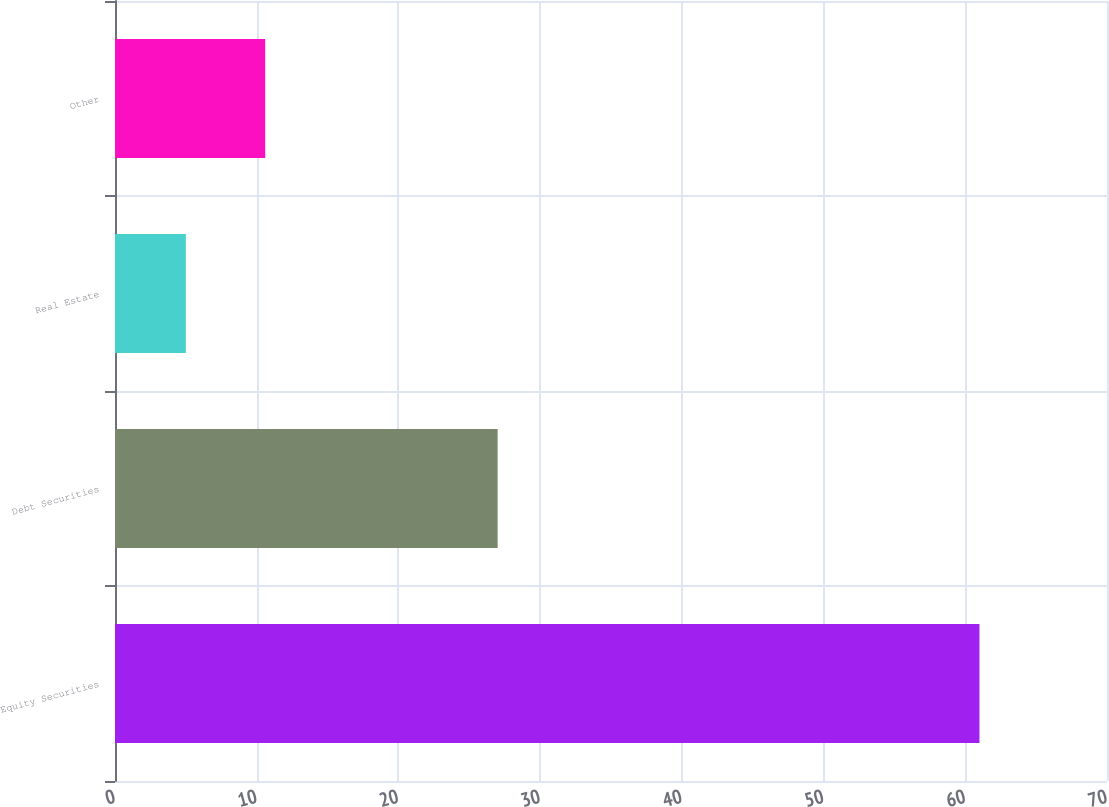Convert chart to OTSL. <chart><loc_0><loc_0><loc_500><loc_500><bar_chart><fcel>Equity Securities<fcel>Debt Securities<fcel>Real Estate<fcel>Other<nl><fcel>61<fcel>27<fcel>5<fcel>10.6<nl></chart> 